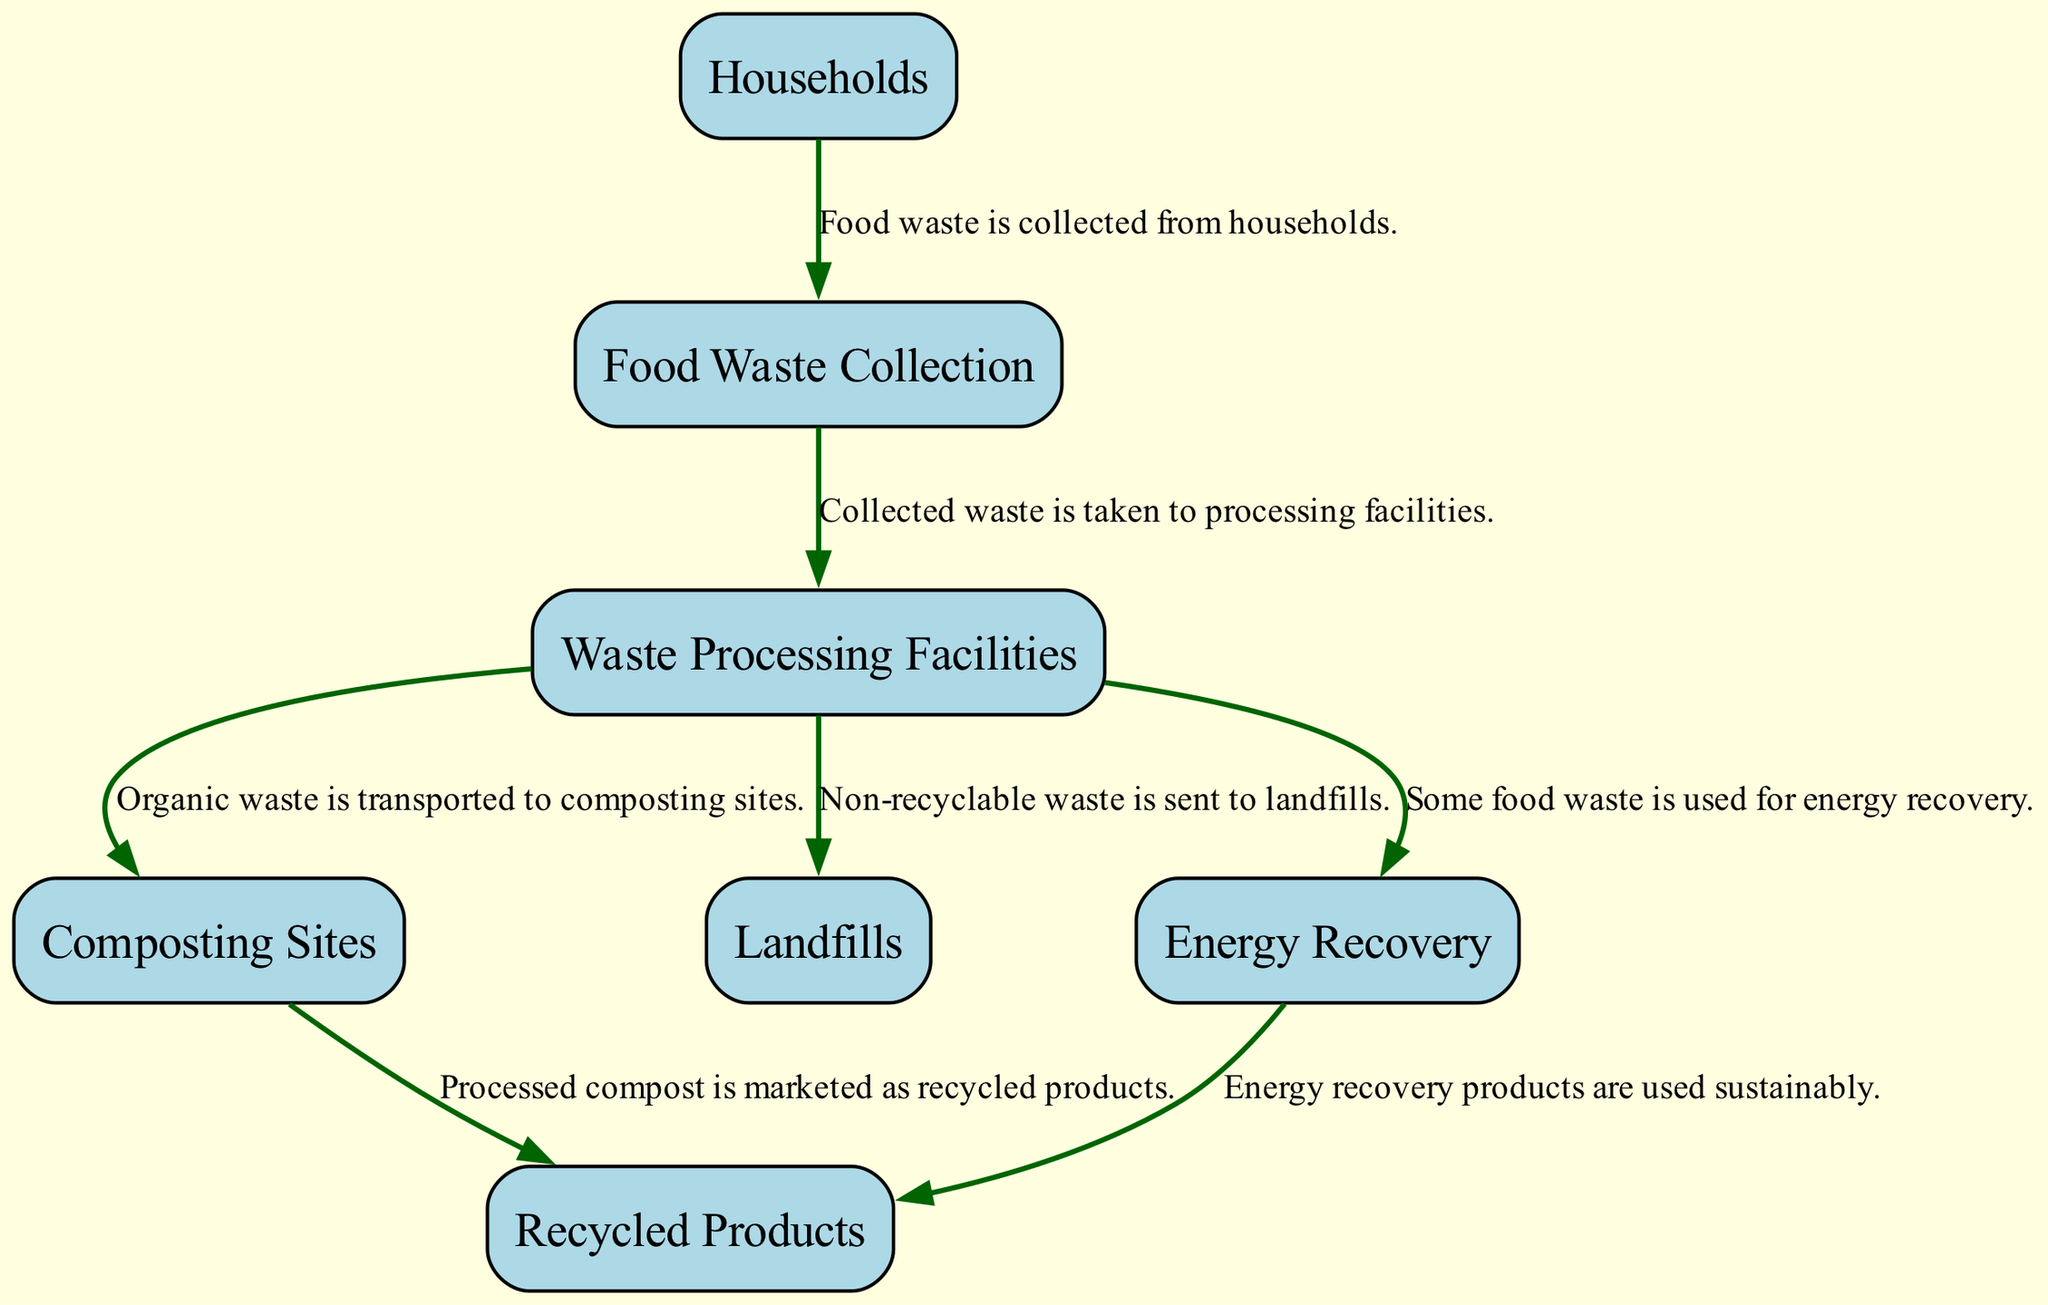What is the primary source of food waste generation? The diagram indicates that "Households" are the primary source of food waste generation in residential areas. This is clearly stated in the description for the "Households" node.
Answer: Households How many nodes are present in the food waste chain? Counting the nodes listed in the diagram, there are 7 distinct nodes present that represent various components in the food waste chain.
Answer: 7 Which node collects food waste from households? From the diagram, it is shown that "Food Waste Collection" is the node responsible for collecting food waste from households, as described in the corresponding edge.
Answer: Food Waste Collection What happens to organic waste after processing? The diagram shows that organic waste is transported to "Composting Sites" after processing at the "Waste Processing Facilities," as indicated by the edge connecting these nodes.
Answer: Composting Sites What type of facilities convert food waste into energy? Referring to the diagram, the "Energy Recovery" facilities are identified as those converting food waste into energy, as explained by the node's description.
Answer: Energy Recovery How many edges connect the "Waste Processing Facilities" node? By examining the edges connected to the "Waste Processing Facilities," it is found that there are 3 edges leading from this node to other nodes in the diagram.
Answer: 3 What do the composting sites produce after processing organic waste? The diagram describes that after processing organic waste at composting sites, the result is "Recycled Products," specifically processed compost being marketed.
Answer: Recycled Products Where does non-recyclable waste go after processing? According to the diagram, non-recyclable waste is sent to "Landfills" after it is processed, as stated in the edge leading from "Waste Processing Facilities" to "Landfills."
Answer: Landfills What types of products are created from energy recovery processes? The diagram illustrates that products created from energy recovery are also categorized as "Recycled Products," connecting the "Energy Recovery" node to the "Recycled Products" node.
Answer: Recycled Products 